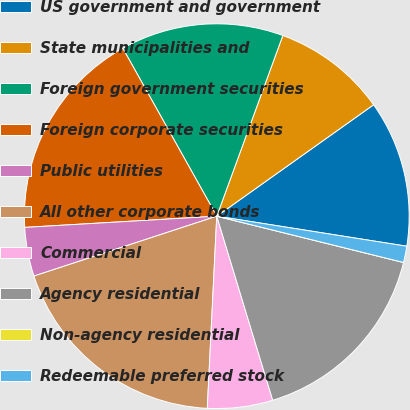Convert chart. <chart><loc_0><loc_0><loc_500><loc_500><pie_chart><fcel>US government and government<fcel>State municipalities and<fcel>Foreign government securities<fcel>Foreign corporate securities<fcel>Public utilities<fcel>All other corporate bonds<fcel>Commercial<fcel>Agency residential<fcel>Non-agency residential<fcel>Redeemable preferred stock<nl><fcel>12.33%<fcel>9.59%<fcel>13.7%<fcel>17.81%<fcel>4.11%<fcel>19.18%<fcel>5.48%<fcel>16.44%<fcel>0.0%<fcel>1.37%<nl></chart> 